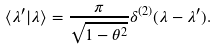<formula> <loc_0><loc_0><loc_500><loc_500>\langle \lambda ^ { \prime } | \lambda \rangle = \frac { \pi } { \sqrt { 1 - \theta ^ { 2 } } } \delta ^ { ( 2 ) } ( \lambda - \lambda ^ { \prime } ) .</formula> 